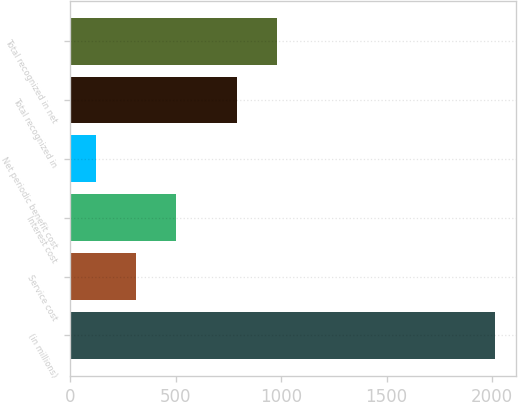<chart> <loc_0><loc_0><loc_500><loc_500><bar_chart><fcel>(in millions)<fcel>Service cost<fcel>Interest cost<fcel>Net periodic benefit cost<fcel>Total recognized in<fcel>Total recognized in net<nl><fcel>2014<fcel>311.2<fcel>500.4<fcel>122<fcel>793<fcel>982.2<nl></chart> 